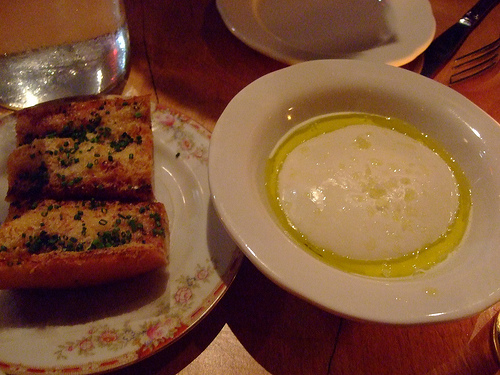<image>
Can you confirm if the food is on the plate? Yes. Looking at the image, I can see the food is positioned on top of the plate, with the plate providing support. 